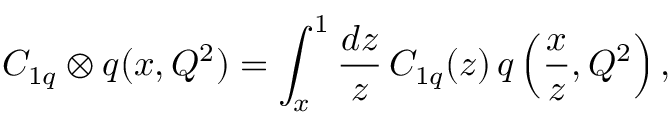<formula> <loc_0><loc_0><loc_500><loc_500>C _ { 1 q } \otimes q ( x , Q ^ { 2 } ) = \int _ { x } ^ { 1 } \frac { d z } { z } \, C _ { 1 q } ( z ) \, q \left ( \frac { x } { z } , Q ^ { 2 } \right ) ,</formula> 